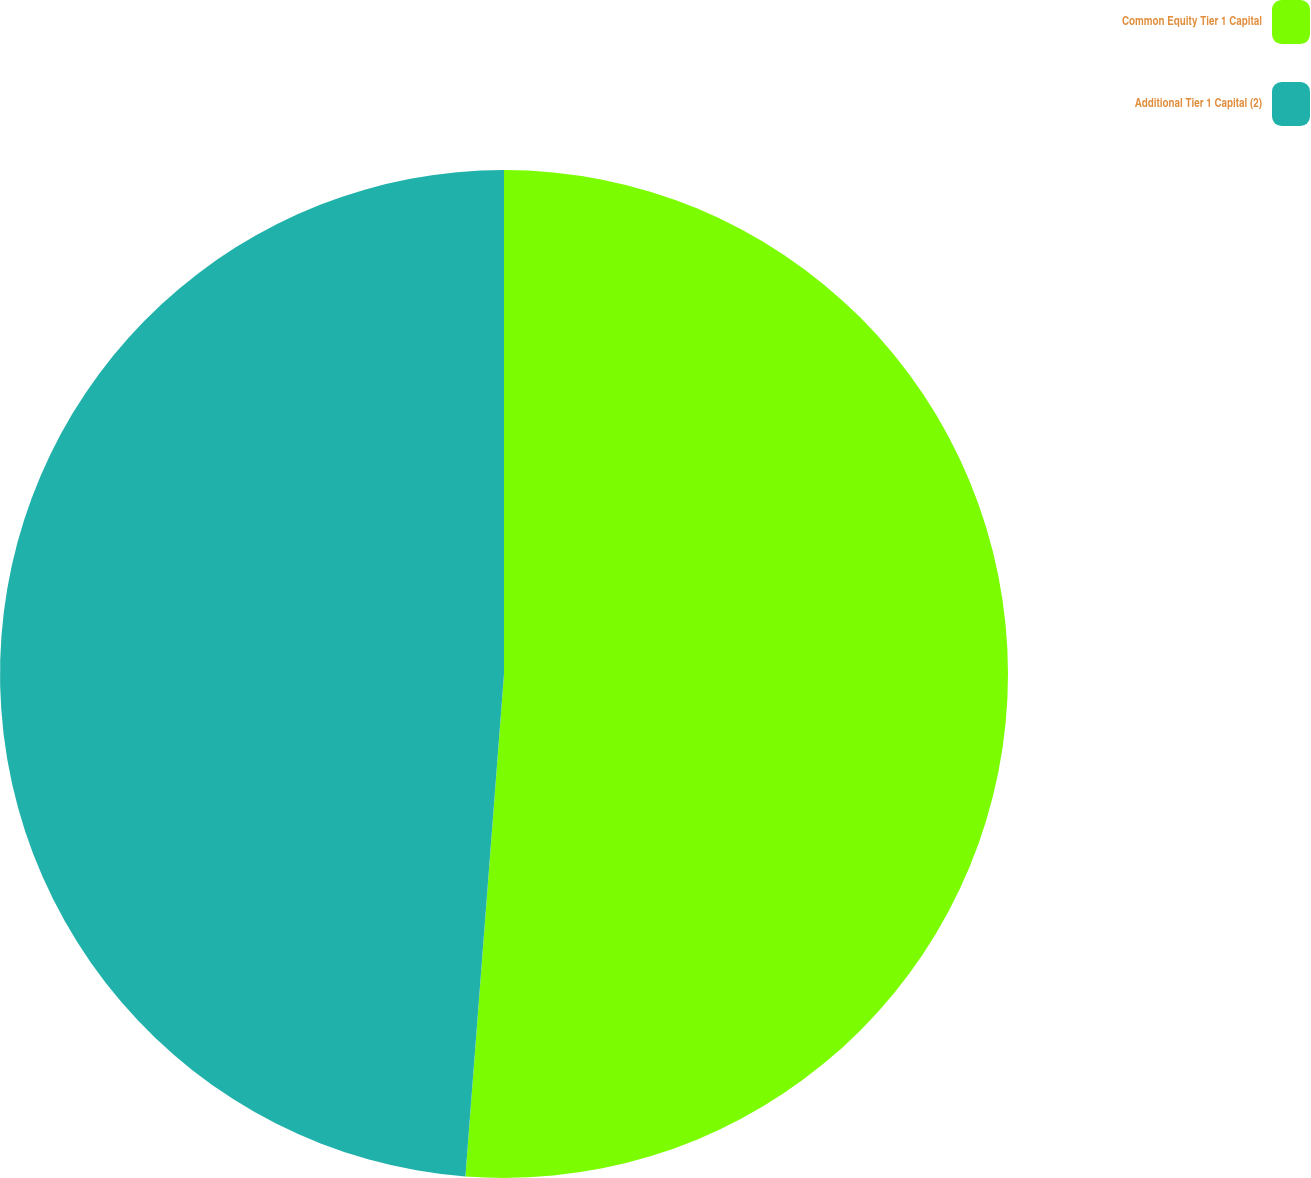Convert chart. <chart><loc_0><loc_0><loc_500><loc_500><pie_chart><fcel>Common Equity Tier 1 Capital<fcel>Additional Tier 1 Capital (2)<nl><fcel>51.22%<fcel>48.78%<nl></chart> 